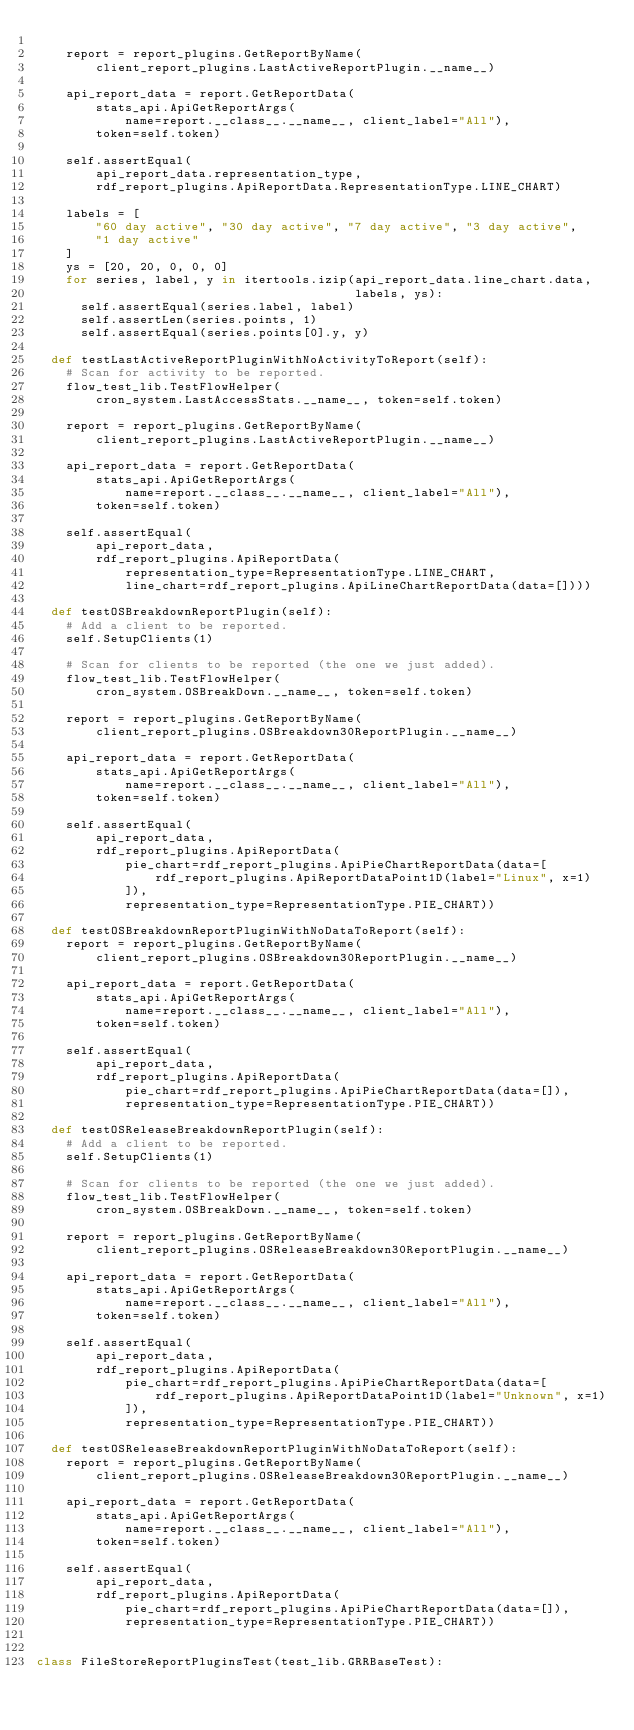Convert code to text. <code><loc_0><loc_0><loc_500><loc_500><_Python_>
    report = report_plugins.GetReportByName(
        client_report_plugins.LastActiveReportPlugin.__name__)

    api_report_data = report.GetReportData(
        stats_api.ApiGetReportArgs(
            name=report.__class__.__name__, client_label="All"),
        token=self.token)

    self.assertEqual(
        api_report_data.representation_type,
        rdf_report_plugins.ApiReportData.RepresentationType.LINE_CHART)

    labels = [
        "60 day active", "30 day active", "7 day active", "3 day active",
        "1 day active"
    ]
    ys = [20, 20, 0, 0, 0]
    for series, label, y in itertools.izip(api_report_data.line_chart.data,
                                           labels, ys):
      self.assertEqual(series.label, label)
      self.assertLen(series.points, 1)
      self.assertEqual(series.points[0].y, y)

  def testLastActiveReportPluginWithNoActivityToReport(self):
    # Scan for activity to be reported.
    flow_test_lib.TestFlowHelper(
        cron_system.LastAccessStats.__name__, token=self.token)

    report = report_plugins.GetReportByName(
        client_report_plugins.LastActiveReportPlugin.__name__)

    api_report_data = report.GetReportData(
        stats_api.ApiGetReportArgs(
            name=report.__class__.__name__, client_label="All"),
        token=self.token)

    self.assertEqual(
        api_report_data,
        rdf_report_plugins.ApiReportData(
            representation_type=RepresentationType.LINE_CHART,
            line_chart=rdf_report_plugins.ApiLineChartReportData(data=[])))

  def testOSBreakdownReportPlugin(self):
    # Add a client to be reported.
    self.SetupClients(1)

    # Scan for clients to be reported (the one we just added).
    flow_test_lib.TestFlowHelper(
        cron_system.OSBreakDown.__name__, token=self.token)

    report = report_plugins.GetReportByName(
        client_report_plugins.OSBreakdown30ReportPlugin.__name__)

    api_report_data = report.GetReportData(
        stats_api.ApiGetReportArgs(
            name=report.__class__.__name__, client_label="All"),
        token=self.token)

    self.assertEqual(
        api_report_data,
        rdf_report_plugins.ApiReportData(
            pie_chart=rdf_report_plugins.ApiPieChartReportData(data=[
                rdf_report_plugins.ApiReportDataPoint1D(label="Linux", x=1)
            ]),
            representation_type=RepresentationType.PIE_CHART))

  def testOSBreakdownReportPluginWithNoDataToReport(self):
    report = report_plugins.GetReportByName(
        client_report_plugins.OSBreakdown30ReportPlugin.__name__)

    api_report_data = report.GetReportData(
        stats_api.ApiGetReportArgs(
            name=report.__class__.__name__, client_label="All"),
        token=self.token)

    self.assertEqual(
        api_report_data,
        rdf_report_plugins.ApiReportData(
            pie_chart=rdf_report_plugins.ApiPieChartReportData(data=[]),
            representation_type=RepresentationType.PIE_CHART))

  def testOSReleaseBreakdownReportPlugin(self):
    # Add a client to be reported.
    self.SetupClients(1)

    # Scan for clients to be reported (the one we just added).
    flow_test_lib.TestFlowHelper(
        cron_system.OSBreakDown.__name__, token=self.token)

    report = report_plugins.GetReportByName(
        client_report_plugins.OSReleaseBreakdown30ReportPlugin.__name__)

    api_report_data = report.GetReportData(
        stats_api.ApiGetReportArgs(
            name=report.__class__.__name__, client_label="All"),
        token=self.token)

    self.assertEqual(
        api_report_data,
        rdf_report_plugins.ApiReportData(
            pie_chart=rdf_report_plugins.ApiPieChartReportData(data=[
                rdf_report_plugins.ApiReportDataPoint1D(label="Unknown", x=1)
            ]),
            representation_type=RepresentationType.PIE_CHART))

  def testOSReleaseBreakdownReportPluginWithNoDataToReport(self):
    report = report_plugins.GetReportByName(
        client_report_plugins.OSReleaseBreakdown30ReportPlugin.__name__)

    api_report_data = report.GetReportData(
        stats_api.ApiGetReportArgs(
            name=report.__class__.__name__, client_label="All"),
        token=self.token)

    self.assertEqual(
        api_report_data,
        rdf_report_plugins.ApiReportData(
            pie_chart=rdf_report_plugins.ApiPieChartReportData(data=[]),
            representation_type=RepresentationType.PIE_CHART))


class FileStoreReportPluginsTest(test_lib.GRRBaseTest):
</code> 